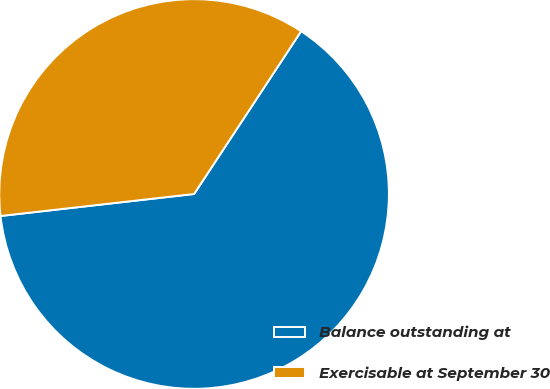Convert chart. <chart><loc_0><loc_0><loc_500><loc_500><pie_chart><fcel>Balance outstanding at<fcel>Exercisable at September 30<nl><fcel>63.94%<fcel>36.06%<nl></chart> 